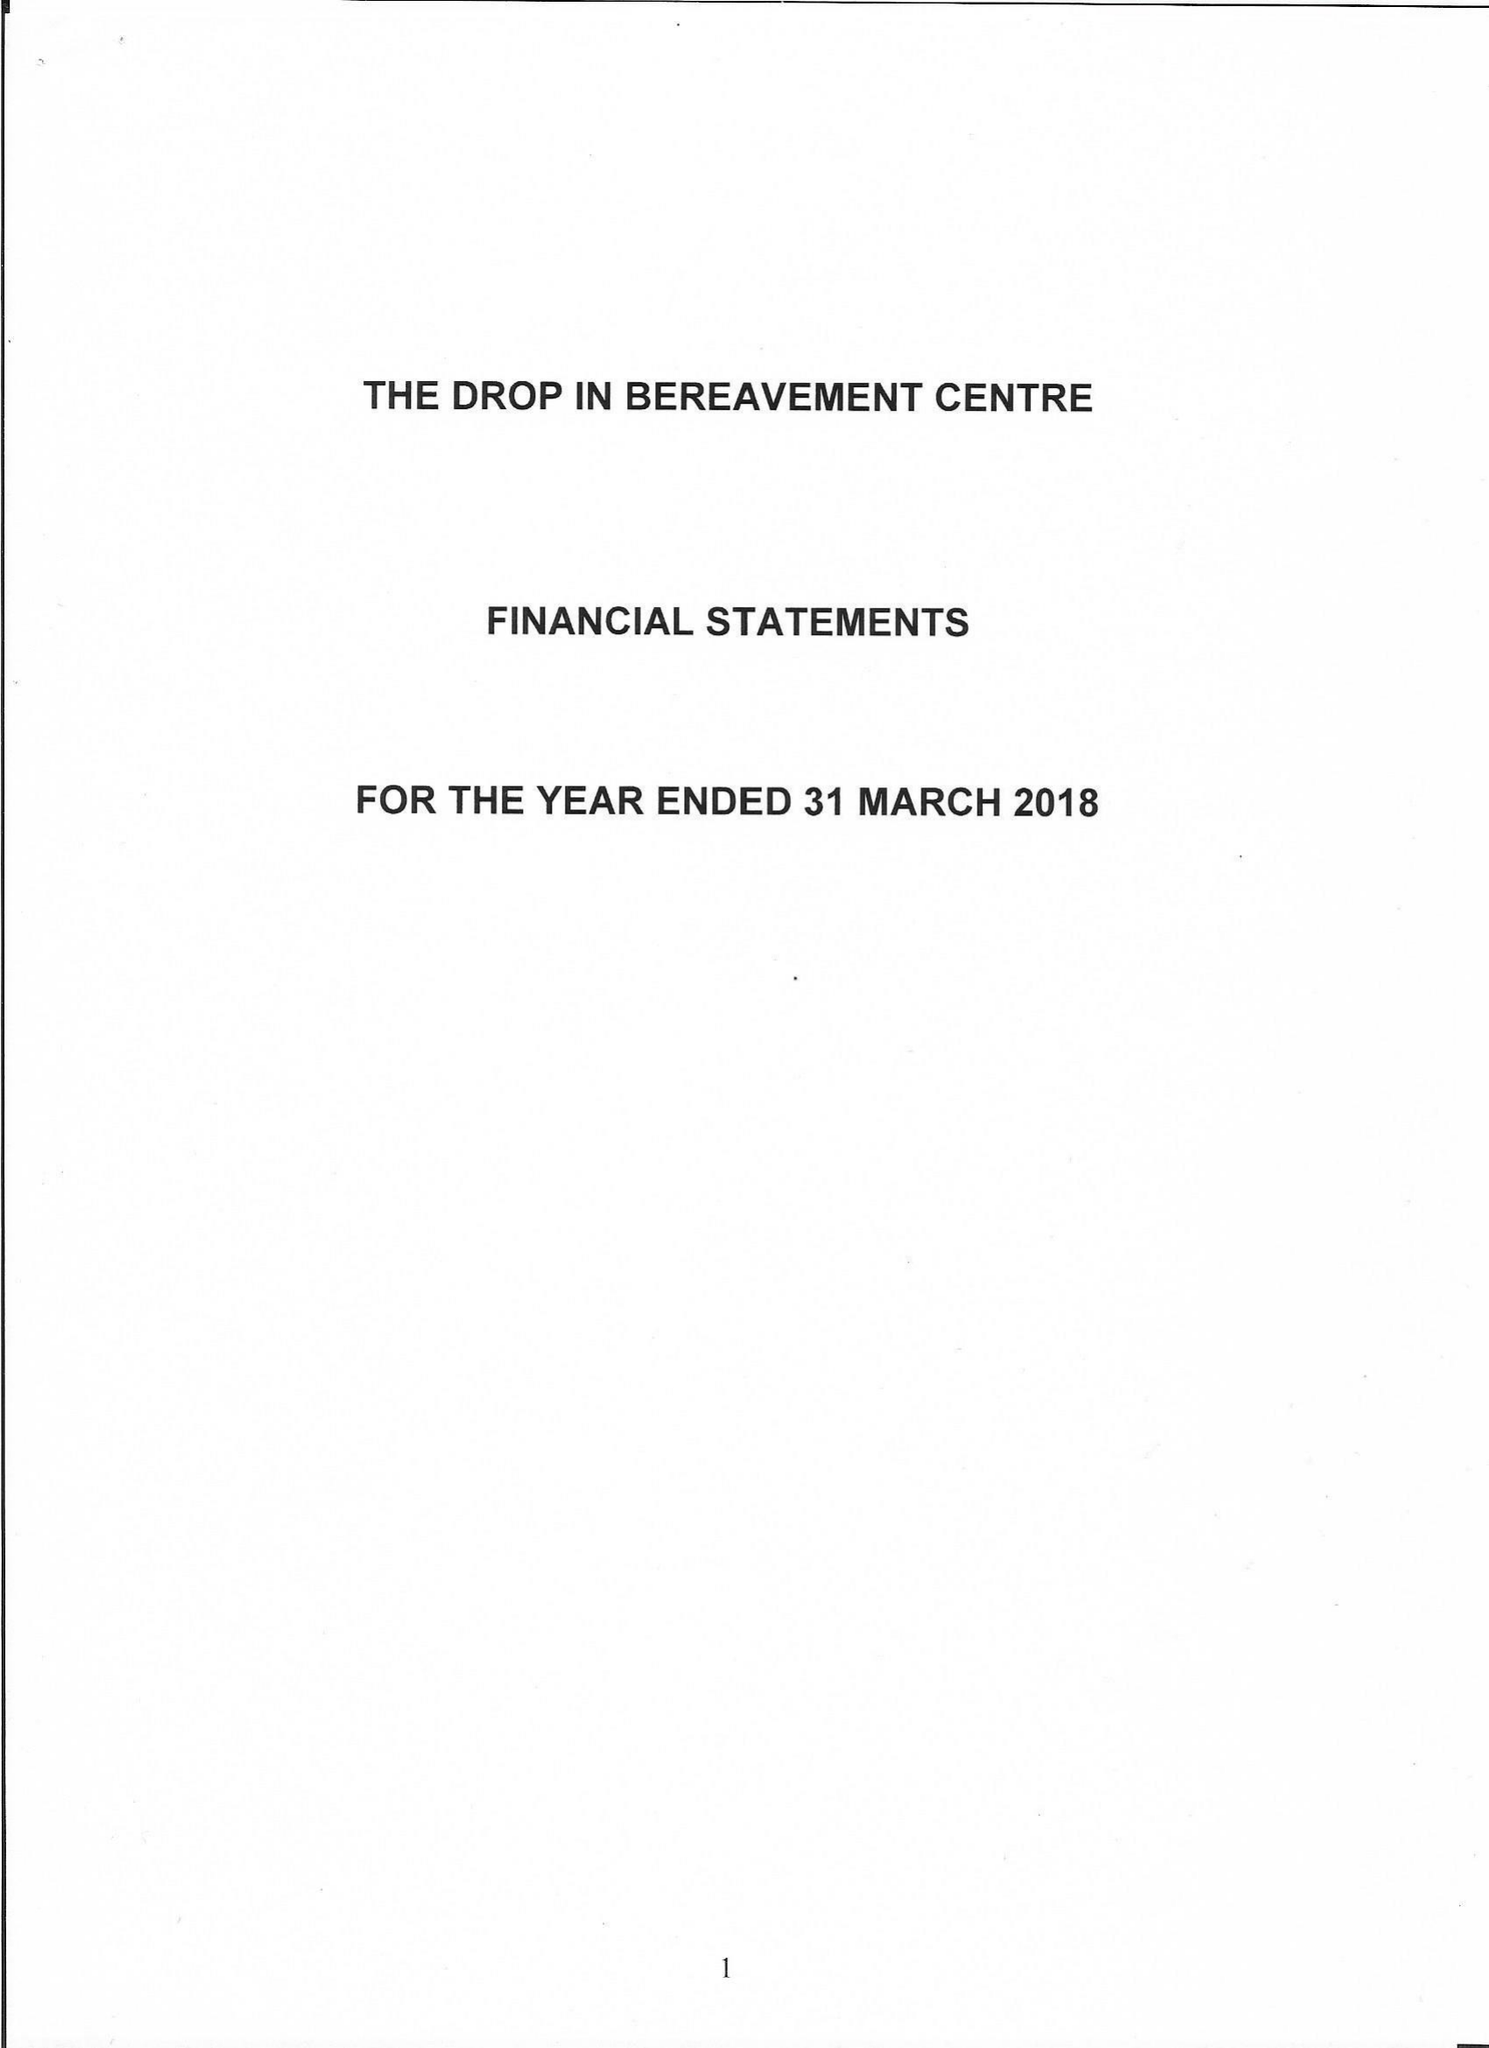What is the value for the charity_number?
Answer the question using a single word or phrase. 1161526 